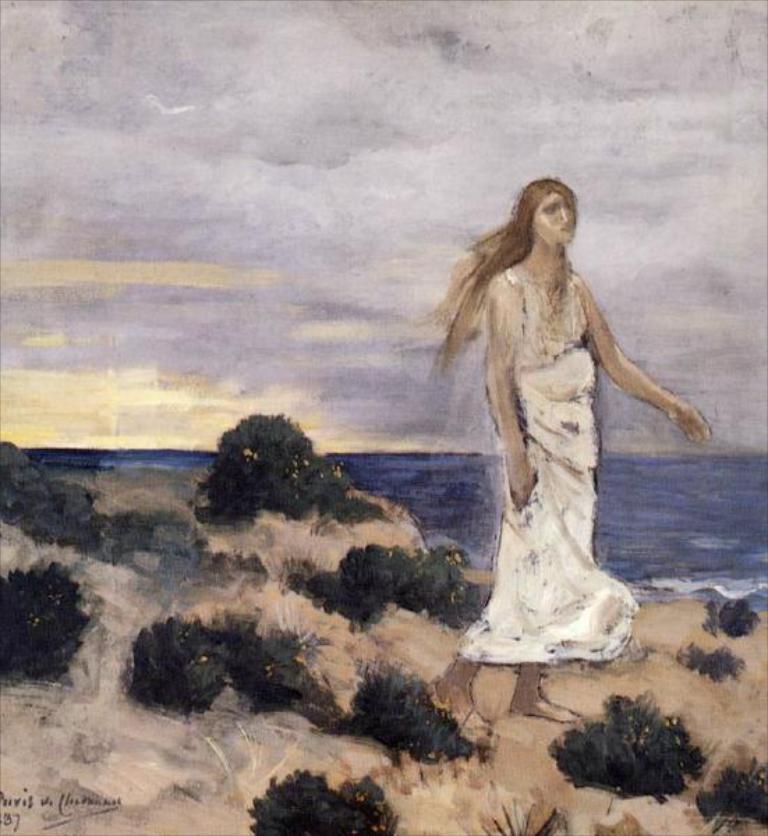In one or two sentences, can you explain what this image depicts? This image consists of a painting. At the bottom of the image there is a ground and there are a few plants on the ground. At the top of the image there is the sky with clouds. In the background there is the sea with water. On the right side of the image a woman is standing on the ground. 